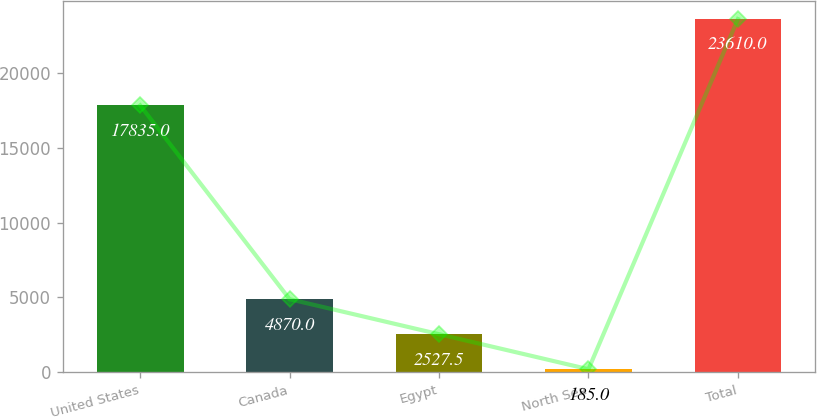Convert chart. <chart><loc_0><loc_0><loc_500><loc_500><bar_chart><fcel>United States<fcel>Canada<fcel>Egypt<fcel>North Sea<fcel>Total<nl><fcel>17835<fcel>4870<fcel>2527.5<fcel>185<fcel>23610<nl></chart> 